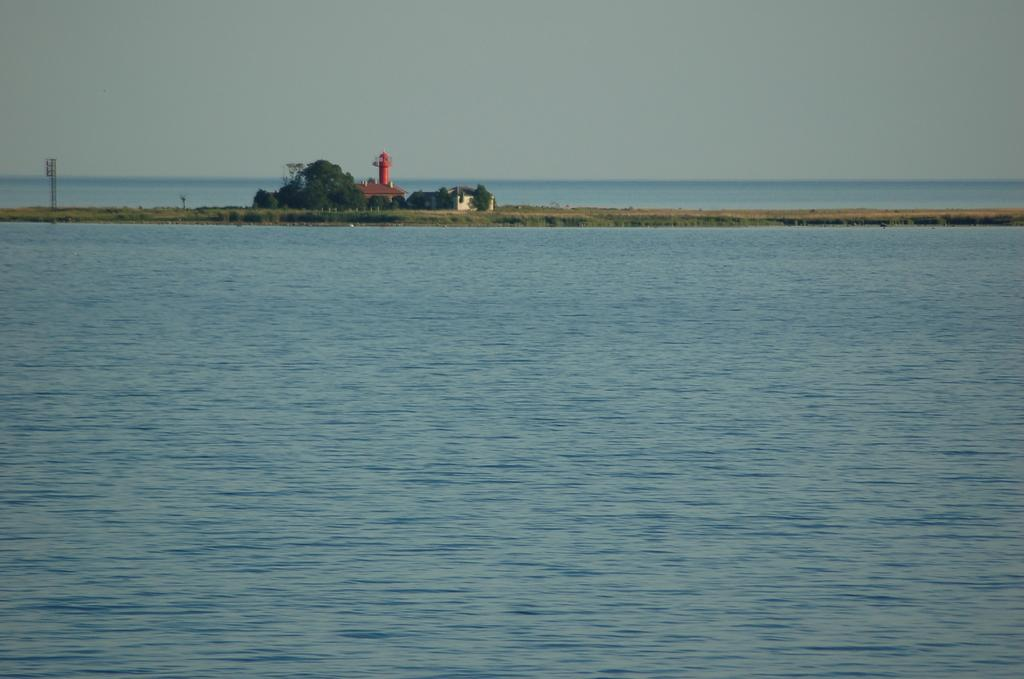What type of natural feature is depicted in the image? There is an ocean in the image. What landmass can be seen in the ocean? There is an island in the image. What type of vegetation is present on the island? Trees are present on the island. What type of structure is on the island? There is a tower on the island. Can you describe the reaction of the chalk to the ocean waves in the image? There is no chalk present in the image, so it is not possible to describe its reaction to the ocean waves. 